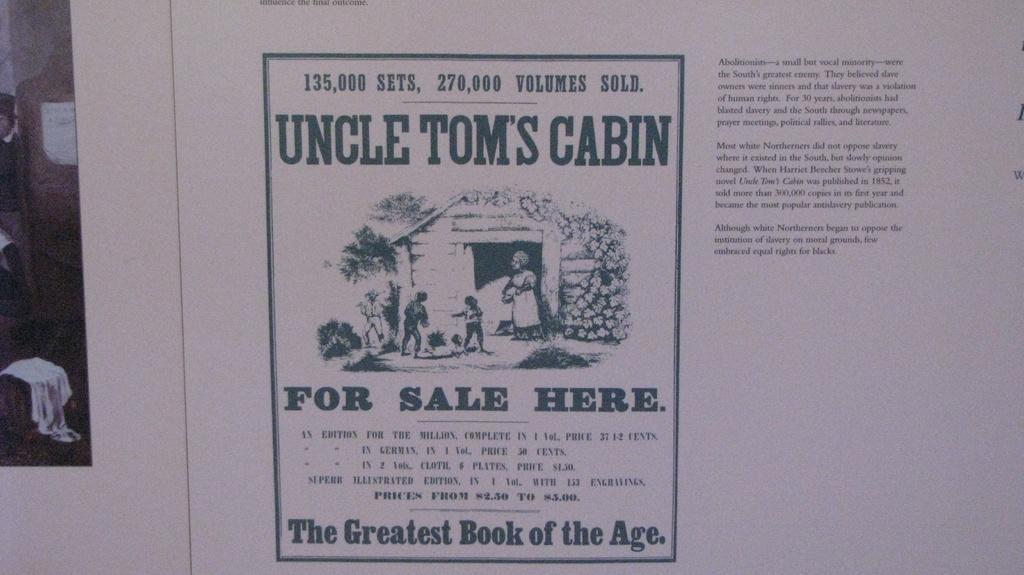In one or two sentences, can you explain what this image depicts? In this image there are some images of a few people and some text. 